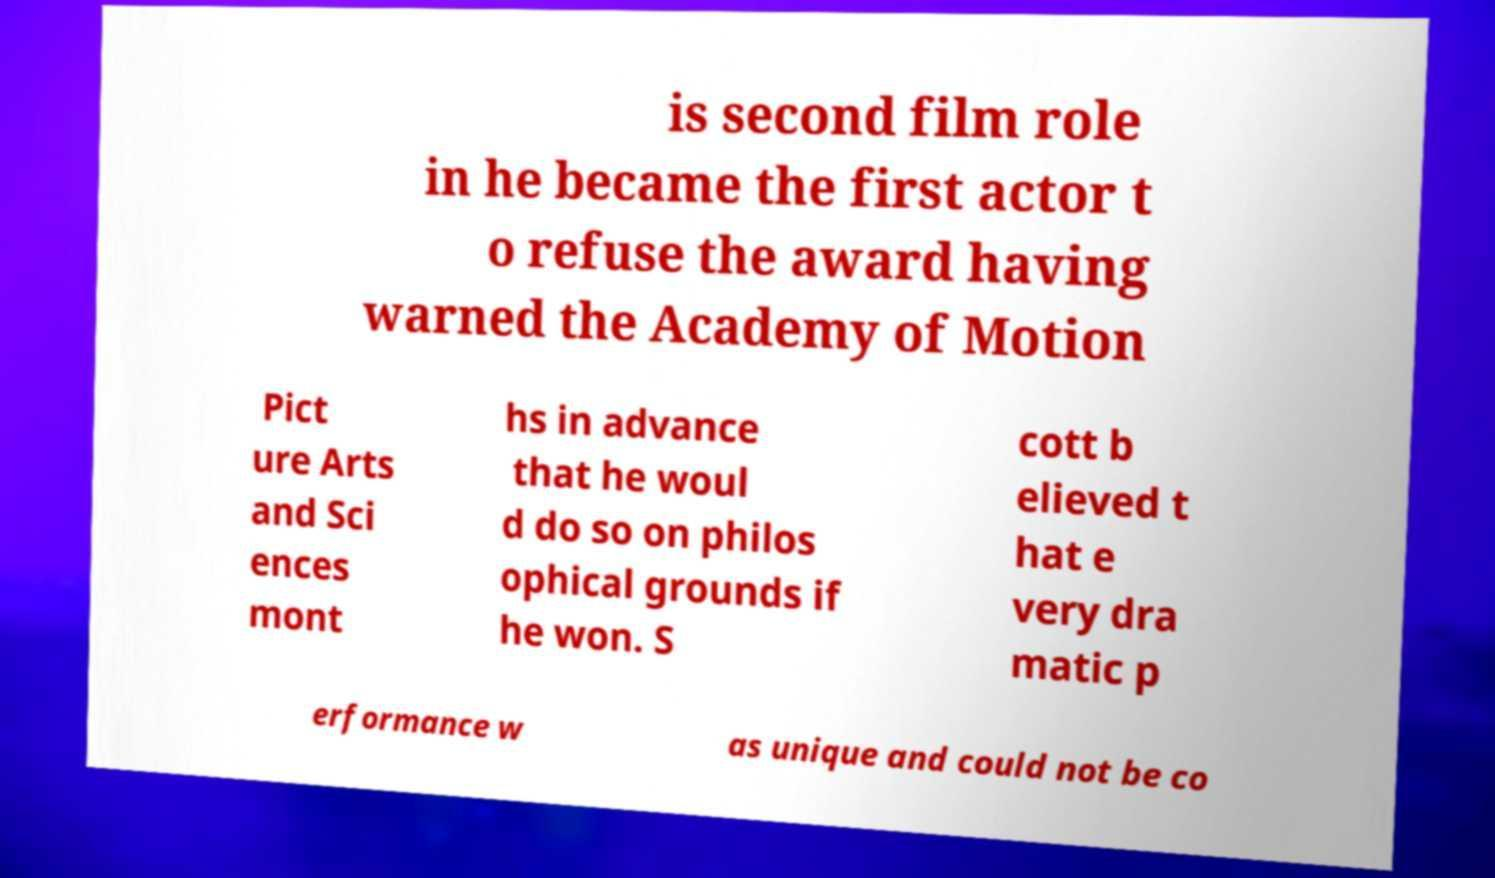Please identify and transcribe the text found in this image. is second film role in he became the first actor t o refuse the award having warned the Academy of Motion Pict ure Arts and Sci ences mont hs in advance that he woul d do so on philos ophical grounds if he won. S cott b elieved t hat e very dra matic p erformance w as unique and could not be co 